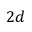<formula> <loc_0><loc_0><loc_500><loc_500>2 d</formula> 